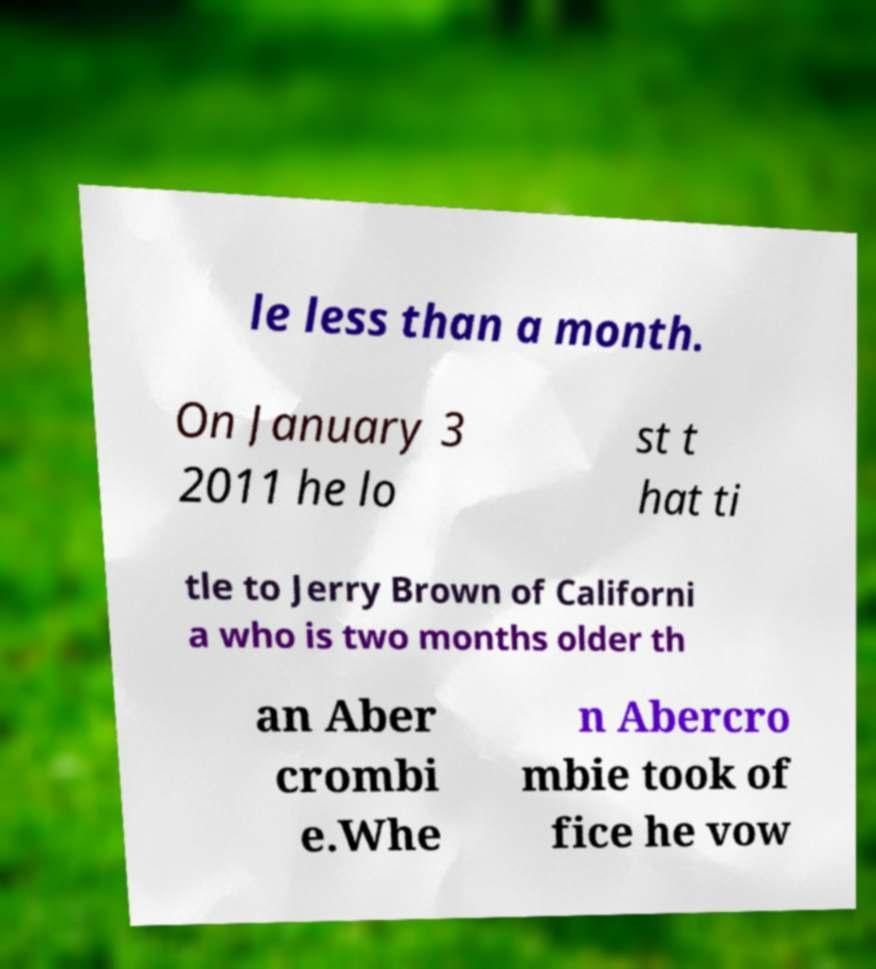Can you read and provide the text displayed in the image?This photo seems to have some interesting text. Can you extract and type it out for me? le less than a month. On January 3 2011 he lo st t hat ti tle to Jerry Brown of Californi a who is two months older th an Aber crombi e.Whe n Abercro mbie took of fice he vow 